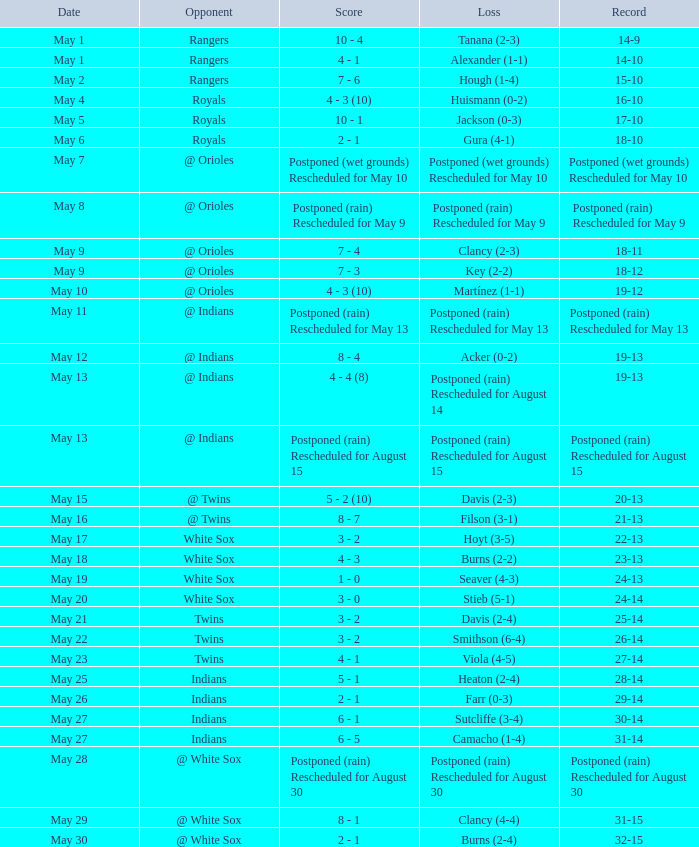What was date of the game when the record was 31-15? May 29. 